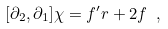<formula> <loc_0><loc_0><loc_500><loc_500>[ \partial _ { 2 } , \partial _ { 1 } ] \chi = f ^ { \prime } r + 2 f \ ,</formula> 